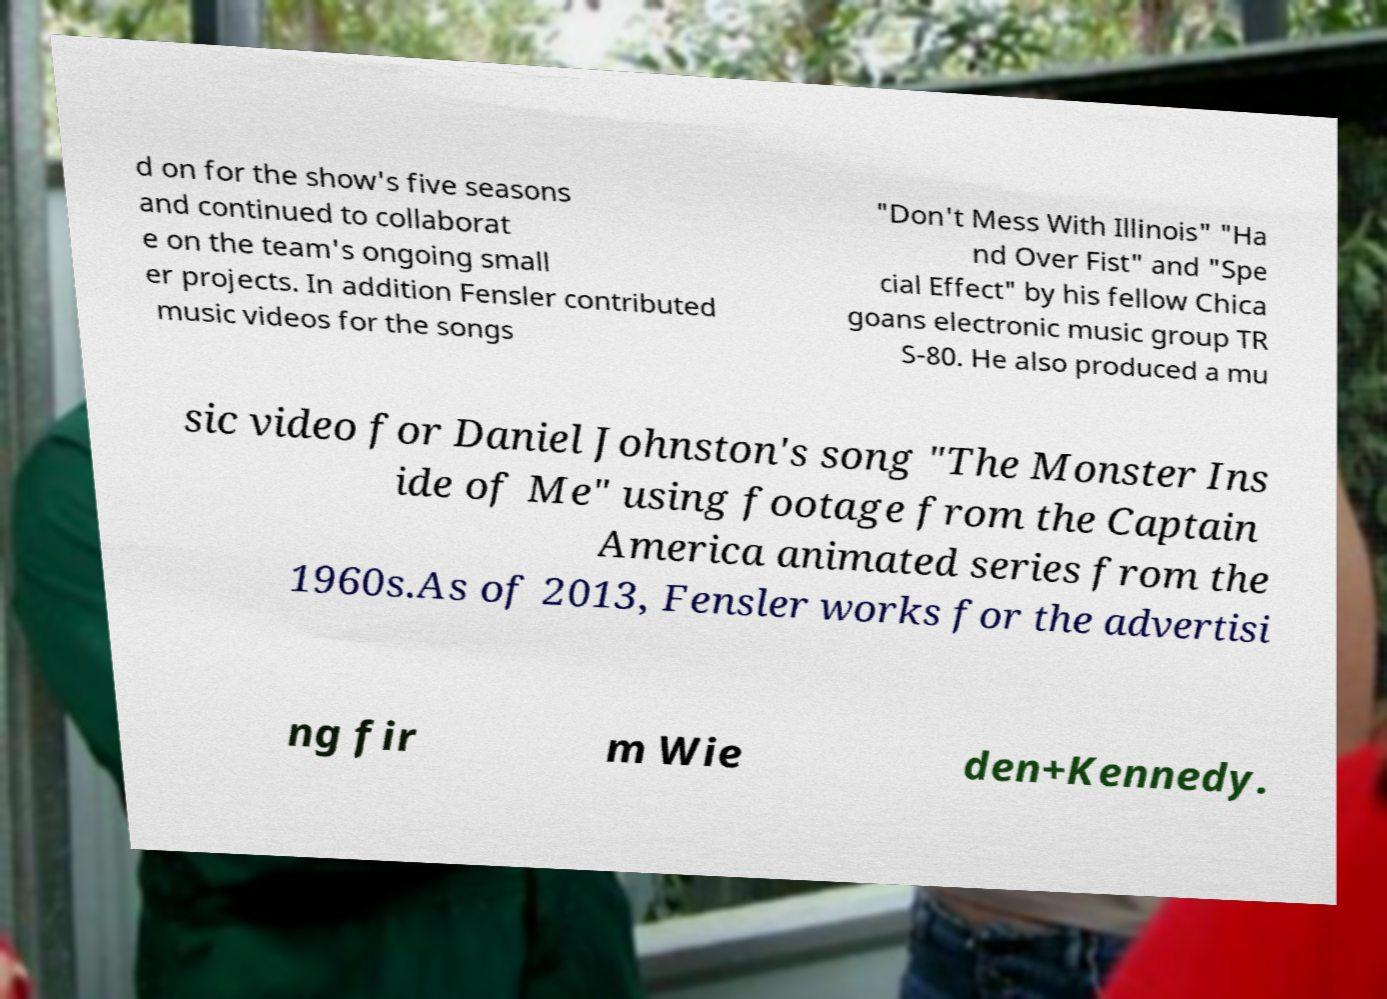For documentation purposes, I need the text within this image transcribed. Could you provide that? d on for the show's five seasons and continued to collaborat e on the team's ongoing small er projects. In addition Fensler contributed music videos for the songs "Don't Mess With Illinois" "Ha nd Over Fist" and "Spe cial Effect" by his fellow Chica goans electronic music group TR S-80. He also produced a mu sic video for Daniel Johnston's song "The Monster Ins ide of Me" using footage from the Captain America animated series from the 1960s.As of 2013, Fensler works for the advertisi ng fir m Wie den+Kennedy. 